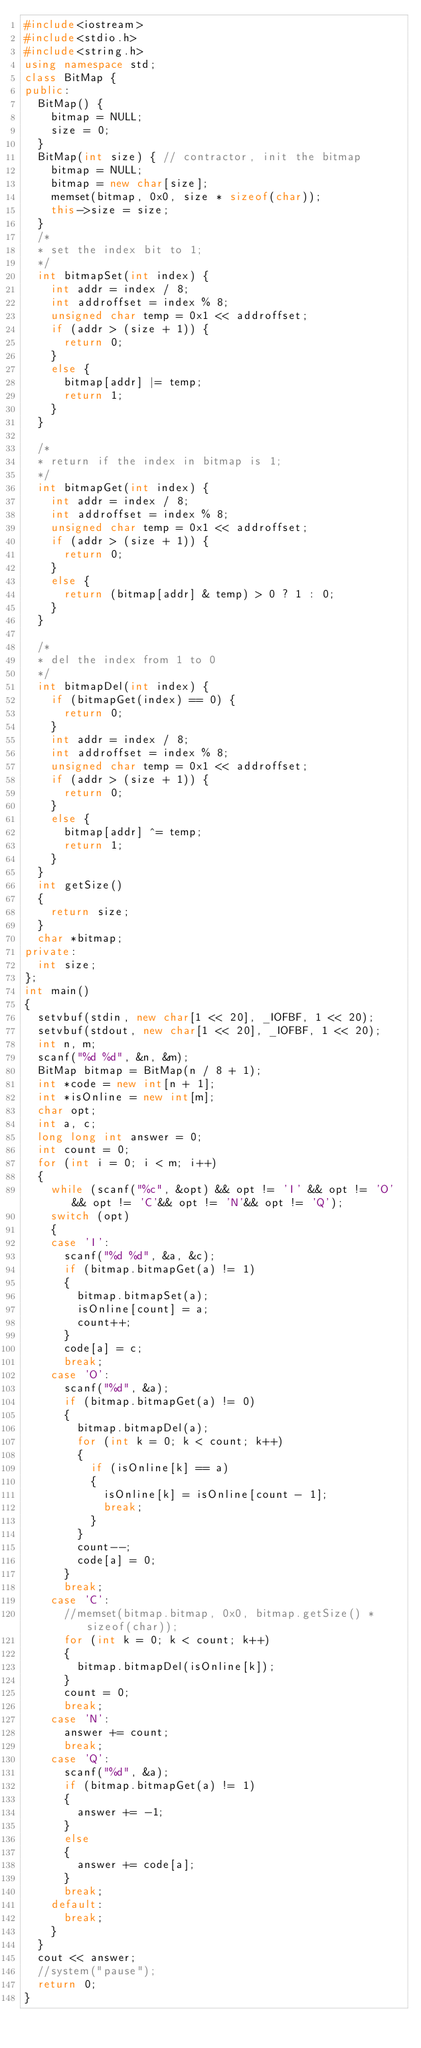Convert code to text. <code><loc_0><loc_0><loc_500><loc_500><_C++_>#include<iostream>
#include<stdio.h>
#include<string.h>
using namespace std;
class BitMap {
public:
	BitMap() {
		bitmap = NULL;
		size = 0;
	}
	BitMap(int size) { // contractor, init the bitmap
		bitmap = NULL;
		bitmap = new char[size];
		memset(bitmap, 0x0, size * sizeof(char));
		this->size = size;
	}
	/*
	* set the index bit to 1;
	*/
	int bitmapSet(int index) {
		int addr = index / 8;
		int addroffset = index % 8;
		unsigned char temp = 0x1 << addroffset;
		if (addr > (size + 1)) {
			return 0;
		}
		else {
			bitmap[addr] |= temp;
			return 1;
		}
	}

	/*
	* return if the index in bitmap is 1;
	*/
	int bitmapGet(int index) {
		int addr = index / 8;
		int addroffset = index % 8;
		unsigned char temp = 0x1 << addroffset;
		if (addr > (size + 1)) {
			return 0;
		}
		else {
			return (bitmap[addr] & temp) > 0 ? 1 : 0;
		}
	}

	/*
	* del the index from 1 to 0
	*/
	int bitmapDel(int index) {
		if (bitmapGet(index) == 0) {
			return 0;
		}
		int addr = index / 8;
		int addroffset = index % 8;
		unsigned char temp = 0x1 << addroffset;
		if (addr > (size + 1)) {
			return 0;
		}
		else {
			bitmap[addr] ^= temp;
			return 1;
		}
	}
	int getSize()
	{
		return size;
	}
	char *bitmap;
private:
	int size;
};
int main()
{
	setvbuf(stdin, new char[1 << 20], _IOFBF, 1 << 20);
	setvbuf(stdout, new char[1 << 20], _IOFBF, 1 << 20);
	int n, m;
	scanf("%d %d", &n, &m);
	BitMap bitmap = BitMap(n / 8 + 1);
	int *code = new int[n + 1];
	int *isOnline = new int[m];
	char opt;
	int a, c;
	long long int answer = 0;
	int count = 0;
	for (int i = 0; i < m; i++)
	{
		while (scanf("%c", &opt) && opt != 'I' && opt != 'O'&& opt != 'C'&& opt != 'N'&& opt != 'Q');
		switch (opt)
		{
		case 'I':
			scanf("%d %d", &a, &c);
			if (bitmap.bitmapGet(a) != 1)
			{
				bitmap.bitmapSet(a);
				isOnline[count] = a;
				count++;
			}
			code[a] = c;
			break;
		case 'O':
			scanf("%d", &a);
			if (bitmap.bitmapGet(a) != 0)
			{
				bitmap.bitmapDel(a);
				for (int k = 0; k < count; k++)
				{
					if (isOnline[k] == a)
					{
						isOnline[k] = isOnline[count - 1];
						break;
					}
				}
				count--;
				code[a] = 0;
			}
			break;
		case 'C':
			//memset(bitmap.bitmap, 0x0, bitmap.getSize() * sizeof(char));
			for (int k = 0; k < count; k++)
			{
				bitmap.bitmapDel(isOnline[k]);
			}
			count = 0;
			break;
		case 'N':
			answer += count;
			break;
		case 'Q':
			scanf("%d", &a);
			if (bitmap.bitmapGet(a) != 1)
			{
				answer += -1;
			}
			else
			{
				answer += code[a];
			}
			break;
		default:
			break;
		}
	}
	cout << answer;
	//system("pause");
	return 0;
}</code> 